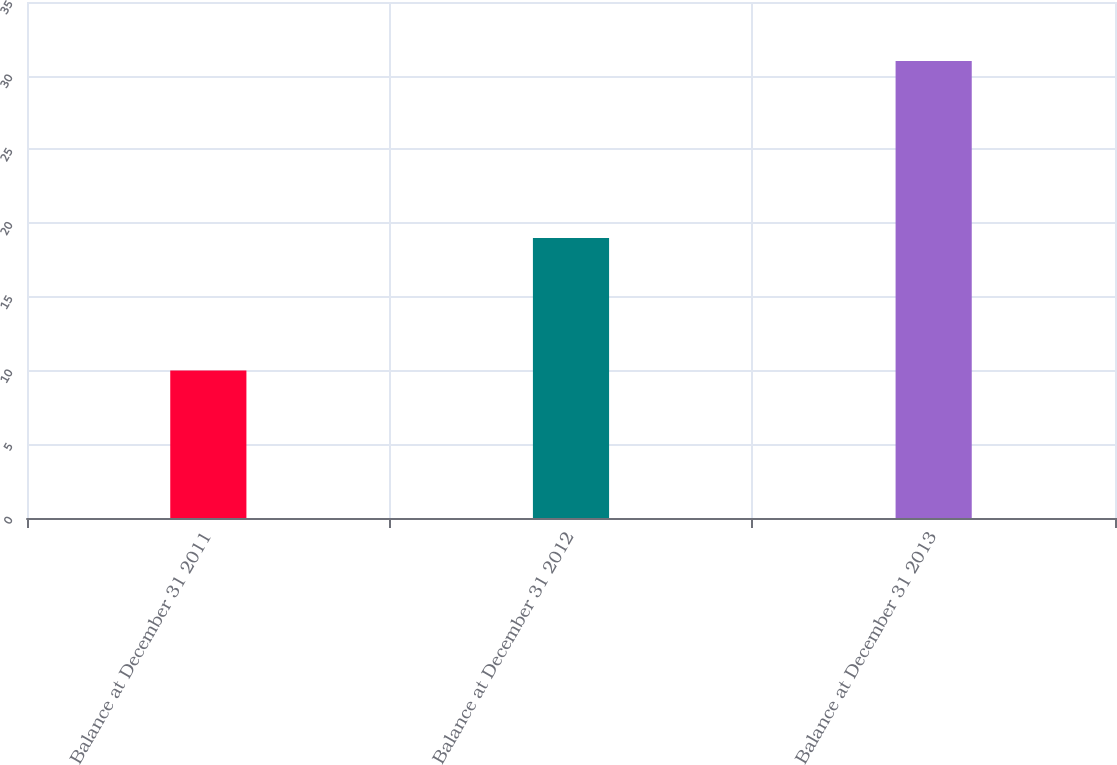Convert chart to OTSL. <chart><loc_0><loc_0><loc_500><loc_500><bar_chart><fcel>Balance at December 31 2011<fcel>Balance at December 31 2012<fcel>Balance at December 31 2013<nl><fcel>10<fcel>19<fcel>31<nl></chart> 